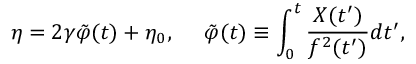<formula> <loc_0><loc_0><loc_500><loc_500>\eta = 2 \gamma \tilde { \varphi } ( t ) + \eta _ { 0 } , \tilde { \varphi } ( t ) \equiv \int _ { 0 } ^ { t } \frac { X ( t ^ { \prime } ) } { f ^ { 2 } ( t ^ { \prime } ) } d t ^ { \prime } ,</formula> 